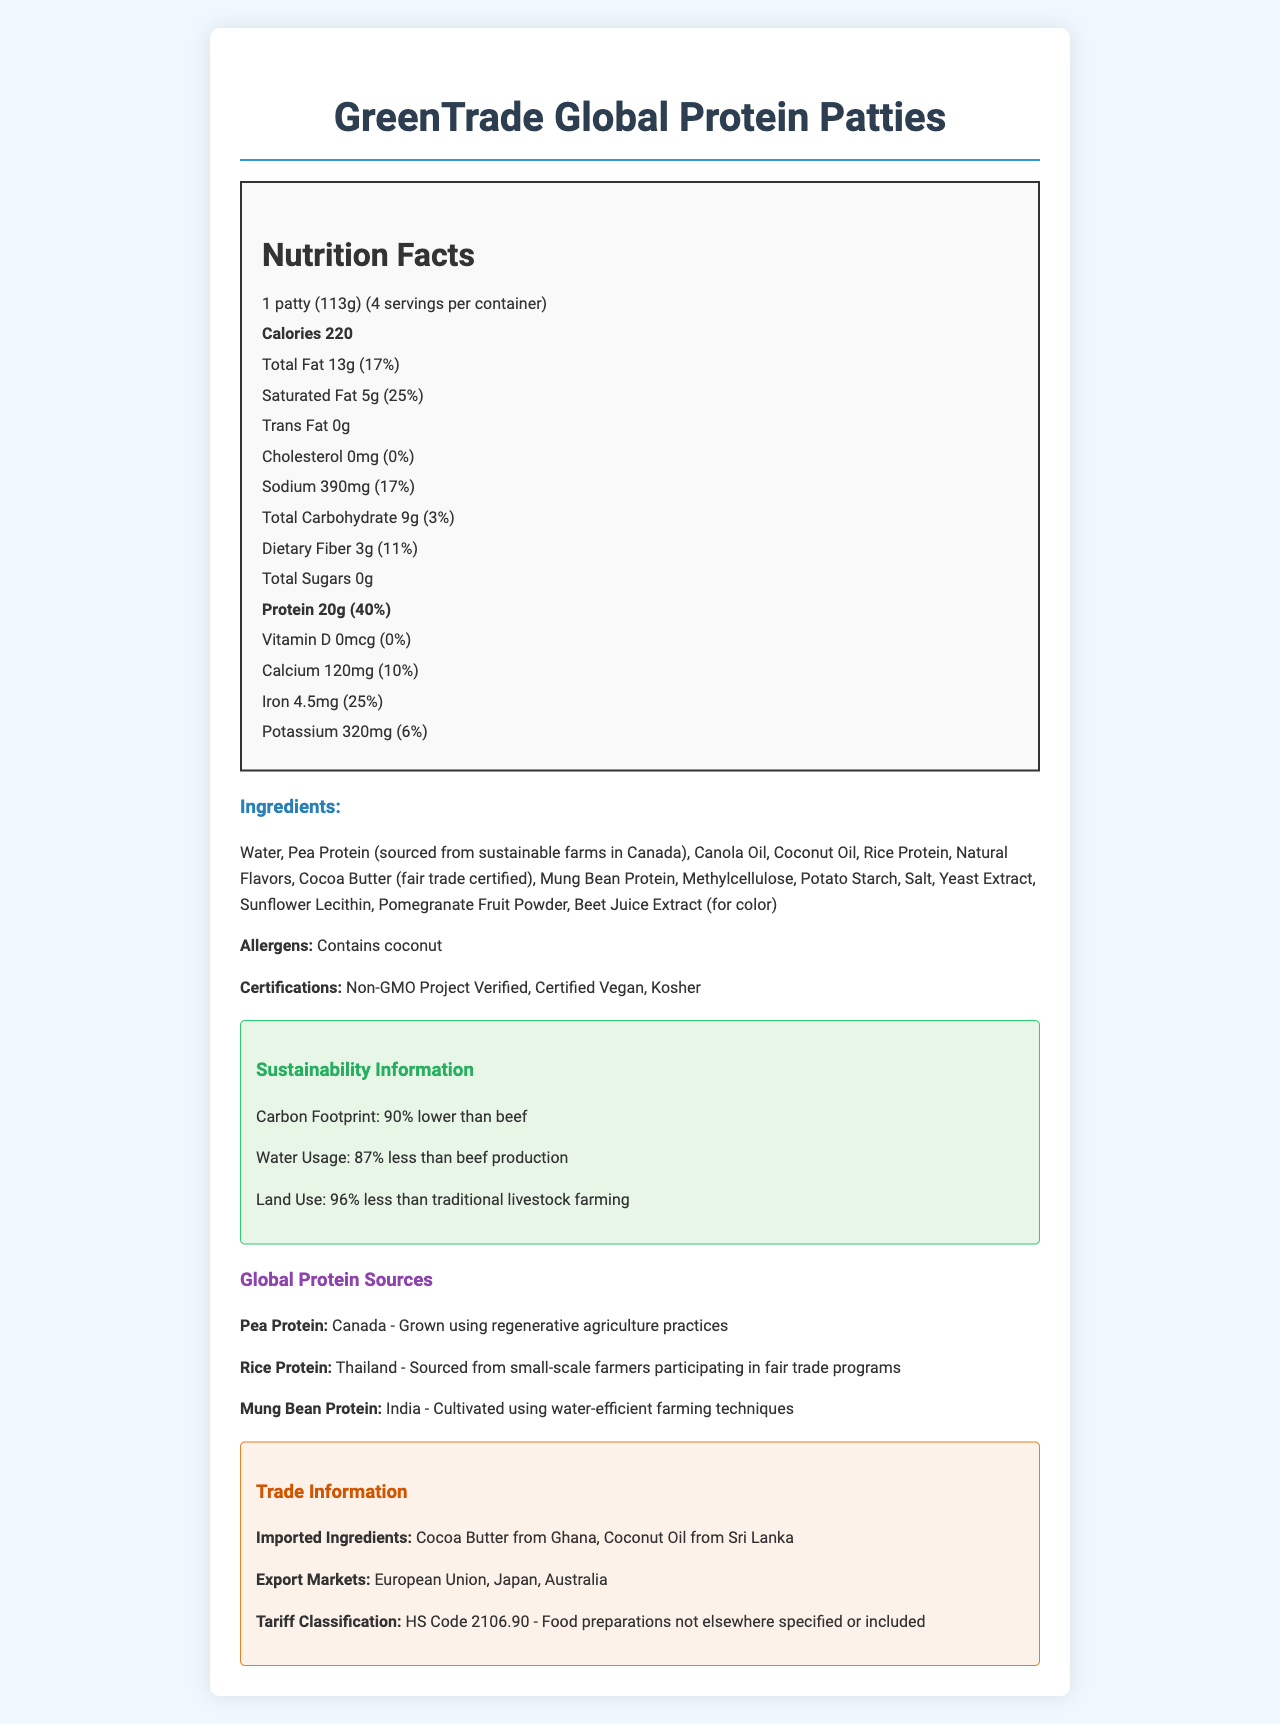what is the serving size for the "GreenTrade Global Protein Patties"? The serving size is explicitly mentioned in the document next to the Nutrition Facts header.
Answer: 1 patty (113g) How many servings are there per container? The number of servings per container is stated right under the serving size information.
Answer: 4 How many grams of protein are there per serving? The protein amount per serving is listed in the nutritional facts under the Protein section.
Answer: 20g What percent of daily value of iron does this product provide? The daily value percentage of iron is clearly listed under the iron section of the Nutrition Facts.
Answer: 25% How much sodium is in one serving? The sodium content per serving is provided in the sodium section of the Nutrition Facts.
Answer: 390mg how much less land use does the "GreenTrade Global Protein Patties" have compared to traditional livestock farming? The sustainability information section mentions that the land use is 96% less compared to traditional livestock farming.
Answer: 96% less Which one of the following certifications does "GreenTrade Global Protein Patties" have? A. USDA Organic B. Non-GMO Project Verified C. Gluten-Free The certifications are listed, and "Non-GMO Project Verified" is explicitly mentioned.
Answer: B Which ingredient is sourced from Ghana? A. Pea Protein B. Rice Protein C. Cocoa Butter The trade information section mentions that Cocoa Butter is sourced from Ghana.
Answer: C Is the product Kosher certified? The certifications section includes Kosher as one of the certifications.
Answer: Yes Summarize the main idea of this document. Main sections of the document include product name, serving size, nutritional information, ingredients, allergens, certifications, sustainability information, global protein sources, and trade information, painting a comprehensive picture of the product's benefits and origins.
Answer: The document provides detailed nutritional, ingredient, sustainability, and trade information for the "GreenTrade Global Protein Patties," emphasizing its environmental benefits and diverse protein sources from across the globe. What is the carbon footprint of this product relative to beef? The sustainability information clearly states that the carbon footprint of this product is 90% lower than beef.
Answer: 90% lower than beef To which regions does "GreenTrade Global Protein Patties" export? The export markets are listed in the trade information section mentioning these three regions.
Answer: European Union, Japan, Australia What is the HS Code for this product? The tariff classification section in the trade information gives the HS Code for this product.
Answer: HS Code 2106.90 What farming techniques are used to cultivate the mung bean protein? The global protein sources section mentions that the mung bean protein from India is cultivated using water-efficient farming techniques.
Answer: Water-efficient farming techniques What daily value of dietary fiber does this product provide? The dietary fiber daily value is listed under the Nutrition Facts section.
Answer: 11% From which country is coconut oil sourced? The trade information section lists coconut oil as sourced from Sri Lanka.
Answer: Sri Lanka What percentage of daily value for calcium does "GreenTrade Global Protein Patties" provide? The percent daily value for calcium is mentioned under the calcium section in the Nutrition Facts.
Answer: 10% What are the ingredients used in the "GreenTrade Global Protein Patties"? The document lists various ingredients (e.g., Water, Pea Protein, Canola Oil), but asking for a complete list or all ingredients at once would be unreasonable for quick identification.
Answer: Cannot be determined What is the total carbohydrate content per serving? The total carbohydrate amount is explicitly listed in the Nutrition Facts section.
Answer: 9g What is the primary protein source, and where is it sourced from? The global protein sources section indicates Pea Protein is the primary protein source and it is sourced from Canada.
Answer: Pea Protein from Canada 